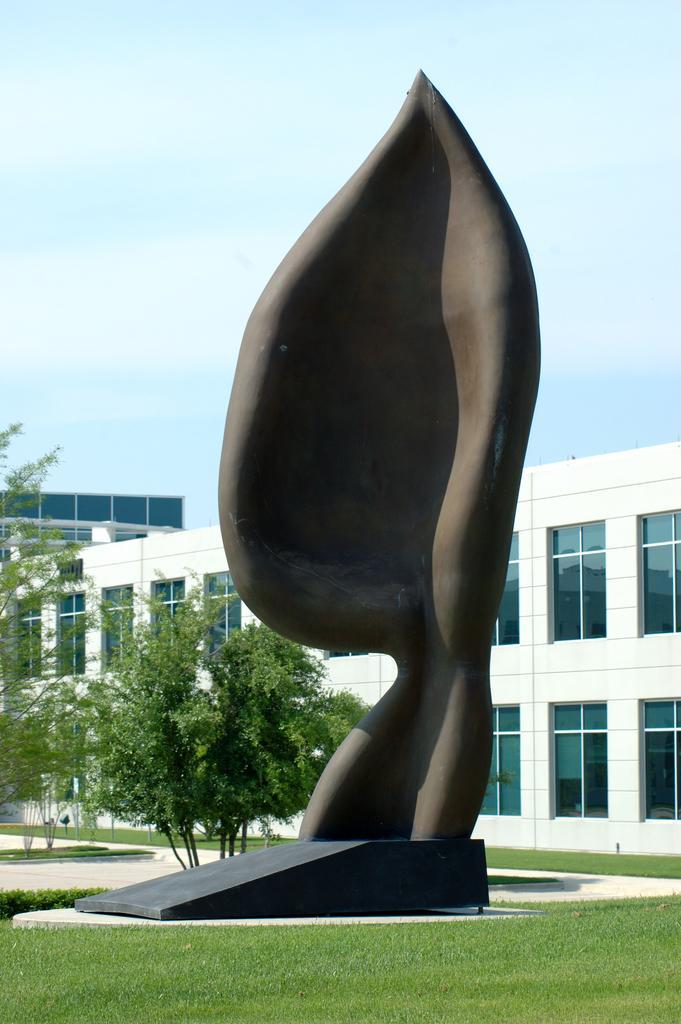Could you give a brief overview of what you see in this image? In the foreground of this image, there is a sculpture and around it there is grass. In the background, there are trees, building, sky and the cloud. 